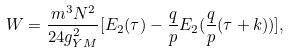<formula> <loc_0><loc_0><loc_500><loc_500>W = \frac { m ^ { 3 } N ^ { 2 } } { 2 4 g _ { Y M } ^ { 2 } } [ E _ { 2 } ( \tau ) - \frac { q } { p } E _ { 2 } ( \frac { q } { p } ( \tau + k ) ) ] ,</formula> 